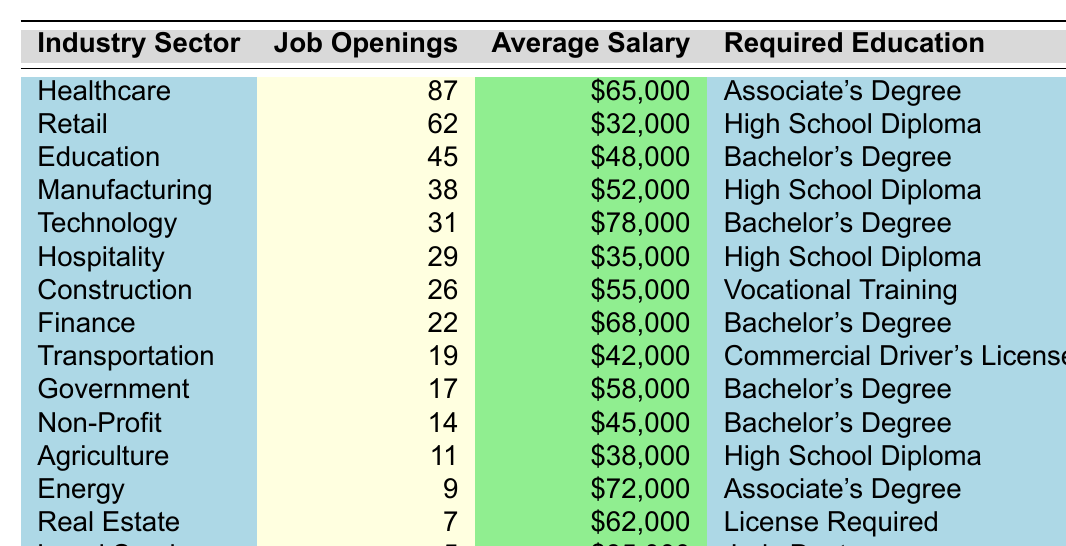What industry sector has the highest number of job openings? The table lists the job openings for each industry sector. By scanning through the numbers, "Healthcare" has the highest number of job openings at 87.
Answer: Healthcare What is the average salary for job openings in the Technology sector? The table indicates that the average salary for the Technology sector is $78,000 as listed under the "Average Salary" column.
Answer: $78,000 How many more job openings are there in the Healthcare sector compared to the Education sector? The Healthcare sector has 87 job openings and the Education sector has 45 openings. To find the difference, subtract: 87 - 45 = 42.
Answer: 42 Is there a job opening available in the Agriculture sector? The table provides 11 job openings for the Agriculture sector, indicating that yes, there are openings available.
Answer: Yes Which sectors require a Bachelor's Degree and have a higher average salary than $60,000? The sectors that require a Bachelor's Degree are Education, Technology, Finance, Government, and Non-Profit. Checking their salaries, Technology ($78,000) and Finance ($68,000) qualify as having higher than $60,000.
Answer: Technology, Finance If you combine the job openings in the Retail and Hospitality sectors, how many job openings do you get? The Retail sector has 62 openings and the Hospitality sector has 29. Adding these together gives: 62 + 29 = 91.
Answer: 91 Is the salary for Legal Services the highest among all sectors listed? According to the table, Legal Services has an average salary of $85,000. Checking all other salaries, Legal Services has the highest salary compared to the rest.
Answer: Yes What is the total number of job openings in the Non-Profit and Agriculture sectors combined? The Non-Profit sector has 14 job openings, while Agriculture has 11. Adding these two gives 14 + 11 = 25.
Answer: 25 Which sector has the lowest number of job openings and what is its average salary? The sector with the lowest job openings is Legal Services, with only 5 openings, and it has an average salary of $85,000.
Answer: Legal Services, $85,000 How many sectors have job openings less than 20? Upon examining the table, only the Transportation and Legal Services sectors have job openings below 20 (19 and 5, respectively), totaling 2 sectors.
Answer: 2 